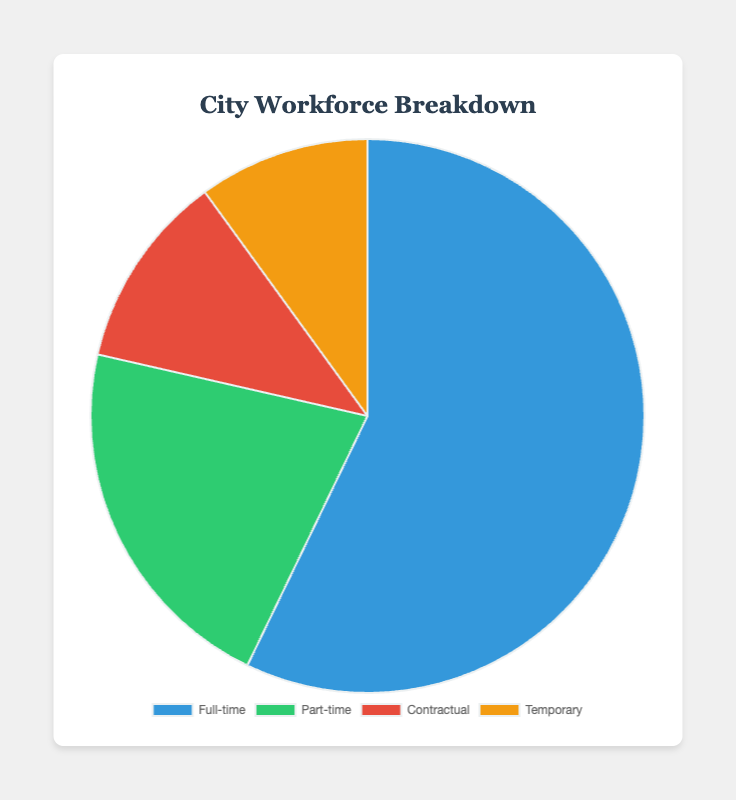What is the total number of full-time and part-time employees? To find the total number of full-time and part-time employees, add the counts from both categories: 4000 (full-time) + 1500 (part-time) = 5500.
Answer: 5500 Which employment type has the smallest share in the city's workforce? Compare the numbers for each employment type (Full-time: 4000, Part-time: 1500, Contractual: 800, Temporary: 700). The temporary category has the smallest count.
Answer: Temporary What percentage of the workforce is employed on a contractual basis? To find the percentage, divide the number of contractual employees by the total number of employees and multiply by 100. Total employees = 4000 + 1500 + 800 + 700 = 7000. So, (800 / 7000) * 100 = 11.4%.
Answer: 11.4% How many more full-time employees are there compared to contractual employees? Subtract the number of contractual employees from the number of full-time employees: 4000 - 800 = 3200.
Answer: 3200 What is the total number of part-time and temporary employees combined? Add the counts from both categories: 1500 (part-time) + 700 (temporary) = 2200.
Answer: 2200 Which employment type is represented by the blue color? Check the color coding provided for each category: Full-time = blue, Part-time = green, Contractual = red, Temporary = yellow. Therefore, full-time employees are represented by the blue color.
Answer: Full-time What is the difference between the number of part-time and temporary employees? Subtract the number of temporary employees from the number of part-time employees: 1500 - 700 = 800.
Answer: 800 If the temporary workforce was increased by 500 employees, what would be the new total workforce? Add 500 to the current number of temporary employees and then recalculate the total workforce: New temporary = 700 + 500 = 1200. Total workforce = 4000 + 1500 + 800 + 1200 = 7500.
Answer: 7500 Among the non-full-time employees (part-time, contractual, and temporary), which category has the largest representation? Compare the numbers for part-time (1500), contractual (800), and temporary (700). Part-time employees have the largest count among non-full-time categories.
Answer: Part-time 